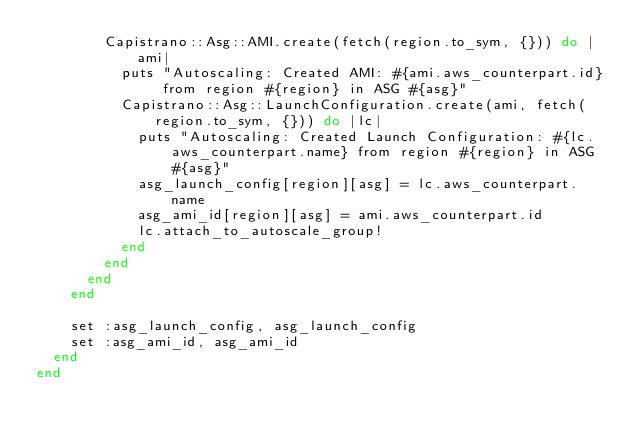<code> <loc_0><loc_0><loc_500><loc_500><_Ruby_>        Capistrano::Asg::AMI.create(fetch(region.to_sym, {})) do |ami|
          puts "Autoscaling: Created AMI: #{ami.aws_counterpart.id} from region #{region} in ASG #{asg}"
          Capistrano::Asg::LaunchConfiguration.create(ami, fetch(region.to_sym, {})) do |lc|
            puts "Autoscaling: Created Launch Configuration: #{lc.aws_counterpart.name} from region #{region} in ASG #{asg}"
            asg_launch_config[region][asg] = lc.aws_counterpart.name
            asg_ami_id[region][asg] = ami.aws_counterpart.id
            lc.attach_to_autoscale_group!
          end
        end
      end
    end

    set :asg_launch_config, asg_launch_config
    set :asg_ami_id, asg_ami_id
  end
end
</code> 